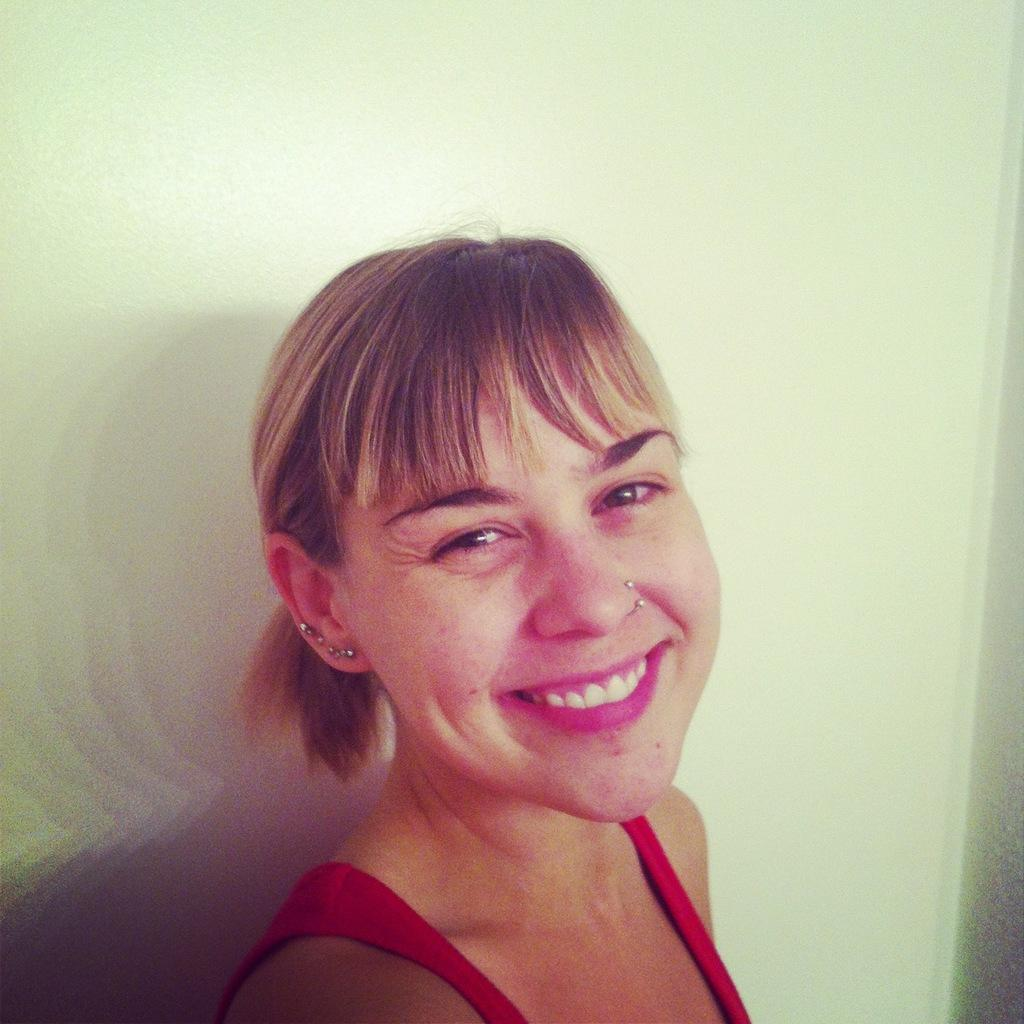Who is present in the image? There is a woman in the image. What is the woman doing in the image? The woman is smiling in the image. What can be seen in the background of the image? There is a white wall in the background of the image. What type of party is the woman attending in the image? There is no mention of a party in the image, so it cannot be determined if the woman is attending a party. 